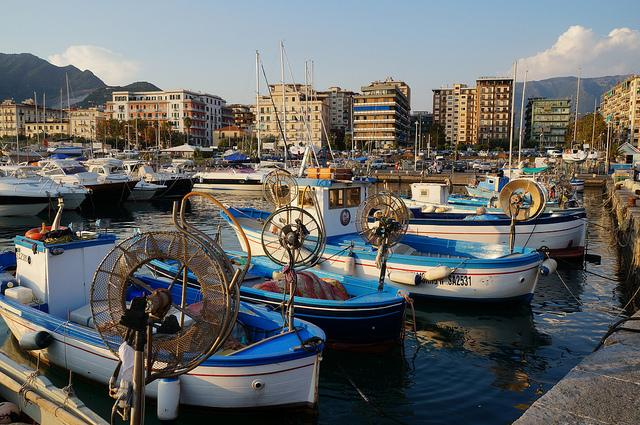What would this location be called? marina 